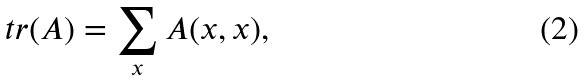<formula> <loc_0><loc_0><loc_500><loc_500>\ t r ( A ) = \sum _ { x } A ( x , x ) ,</formula> 